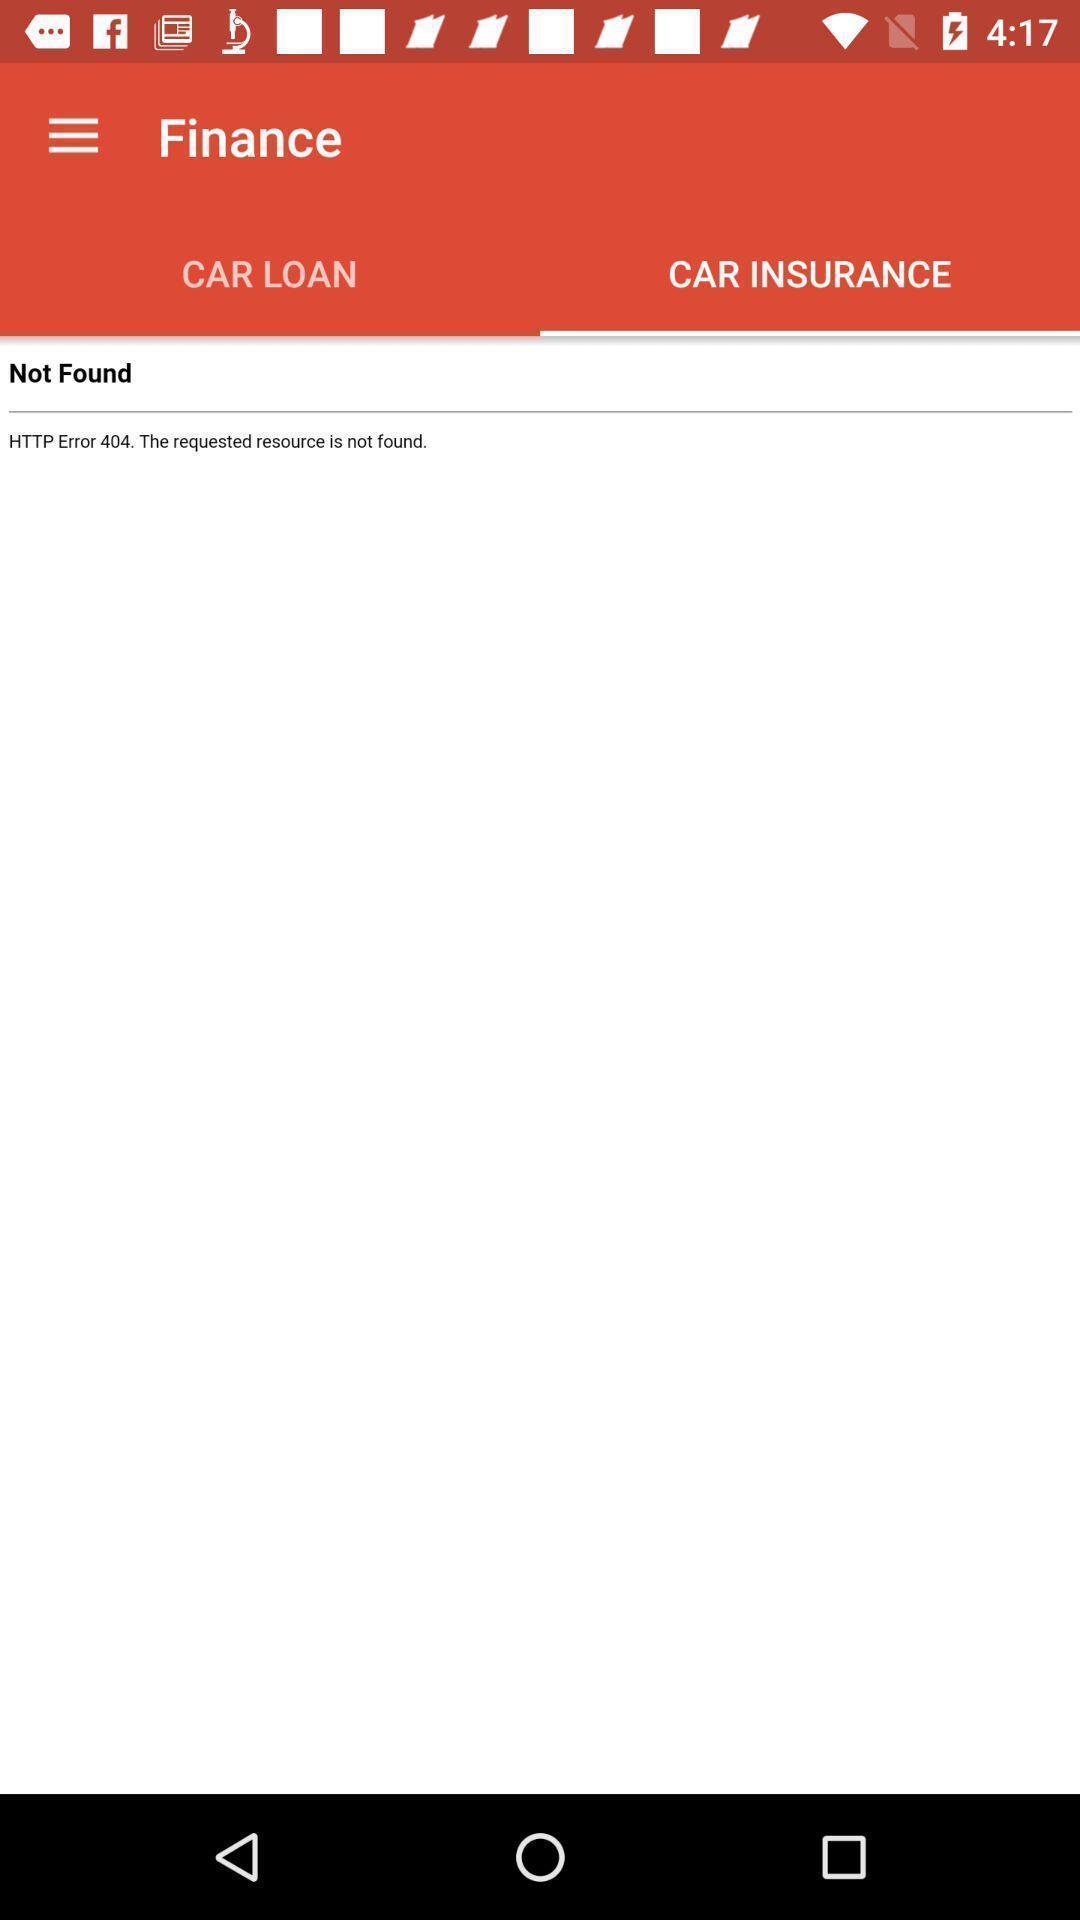Tell me what you see in this picture. Screen shows insurance page in the car application. 